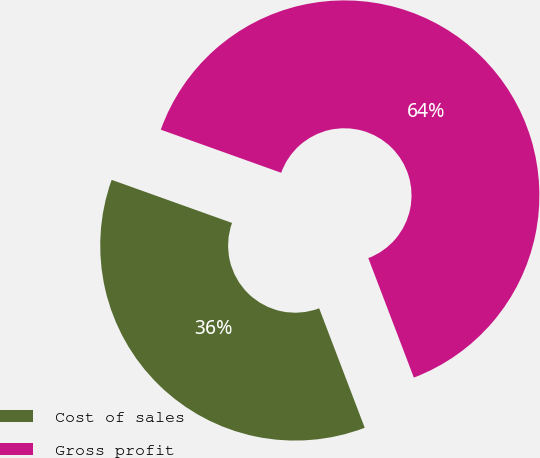<chart> <loc_0><loc_0><loc_500><loc_500><pie_chart><fcel>Cost of sales<fcel>Gross profit<nl><fcel>36.27%<fcel>63.73%<nl></chart> 